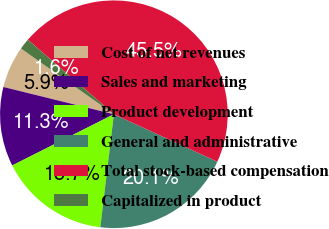Convert chart to OTSL. <chart><loc_0><loc_0><loc_500><loc_500><pie_chart><fcel>Cost of net revenues<fcel>Sales and marketing<fcel>Product development<fcel>General and administrative<fcel>Total stock-based compensation<fcel>Capitalized in product<nl><fcel>5.95%<fcel>11.28%<fcel>15.67%<fcel>20.06%<fcel>45.48%<fcel>1.56%<nl></chart> 